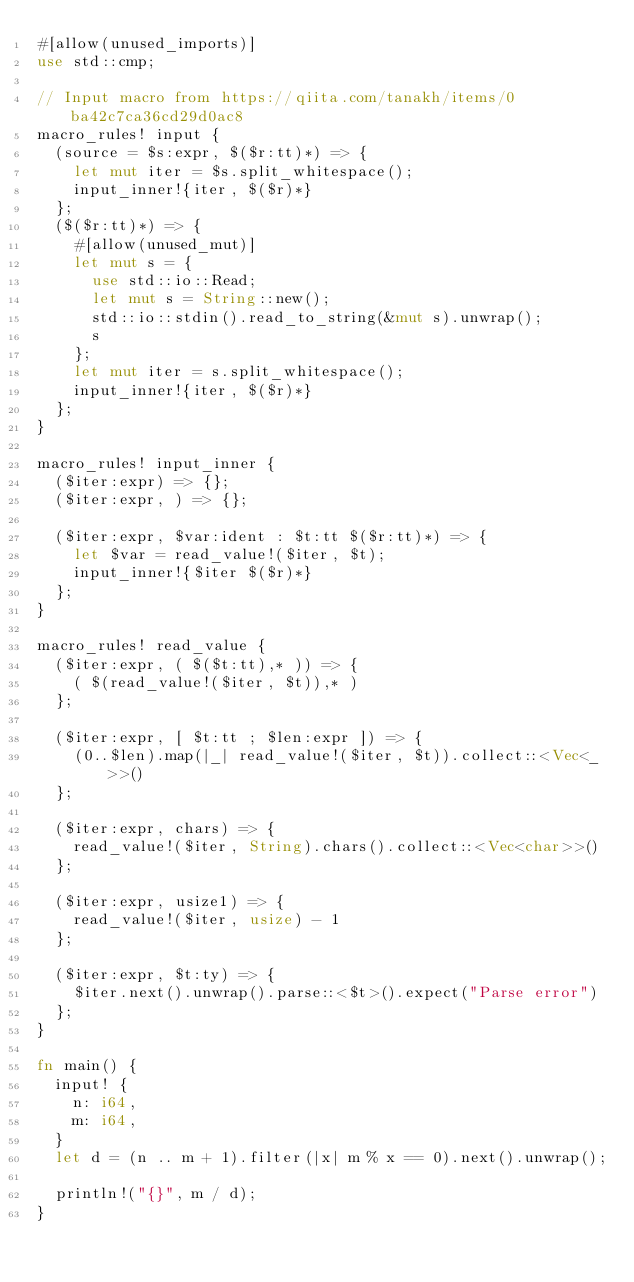Convert code to text. <code><loc_0><loc_0><loc_500><loc_500><_Rust_>#[allow(unused_imports)]
use std::cmp;

// Input macro from https://qiita.com/tanakh/items/0ba42c7ca36cd29d0ac8
macro_rules! input {
  (source = $s:expr, $($r:tt)*) => {
    let mut iter = $s.split_whitespace();
    input_inner!{iter, $($r)*}
  };
  ($($r:tt)*) => {
    #[allow(unused_mut)]
    let mut s = {
      use std::io::Read;
      let mut s = String::new();
      std::io::stdin().read_to_string(&mut s).unwrap();
      s
    };
    let mut iter = s.split_whitespace();
    input_inner!{iter, $($r)*}
  };
}

macro_rules! input_inner {
  ($iter:expr) => {};
  ($iter:expr, ) => {};

  ($iter:expr, $var:ident : $t:tt $($r:tt)*) => {
    let $var = read_value!($iter, $t);
    input_inner!{$iter $($r)*}
  };
}

macro_rules! read_value {
  ($iter:expr, ( $($t:tt),* )) => {
    ( $(read_value!($iter, $t)),* )
  };

  ($iter:expr, [ $t:tt ; $len:expr ]) => {
    (0..$len).map(|_| read_value!($iter, $t)).collect::<Vec<_>>()
  };

  ($iter:expr, chars) => {
    read_value!($iter, String).chars().collect::<Vec<char>>()
  };

  ($iter:expr, usize1) => {
    read_value!($iter, usize) - 1
  };

  ($iter:expr, $t:ty) => {
    $iter.next().unwrap().parse::<$t>().expect("Parse error")
  };
}

fn main() {
  input! {
    n: i64,
    m: i64,
  }
  let d = (n .. m + 1).filter(|x| m % x == 0).next().unwrap();

  println!("{}", m / d);
}
</code> 